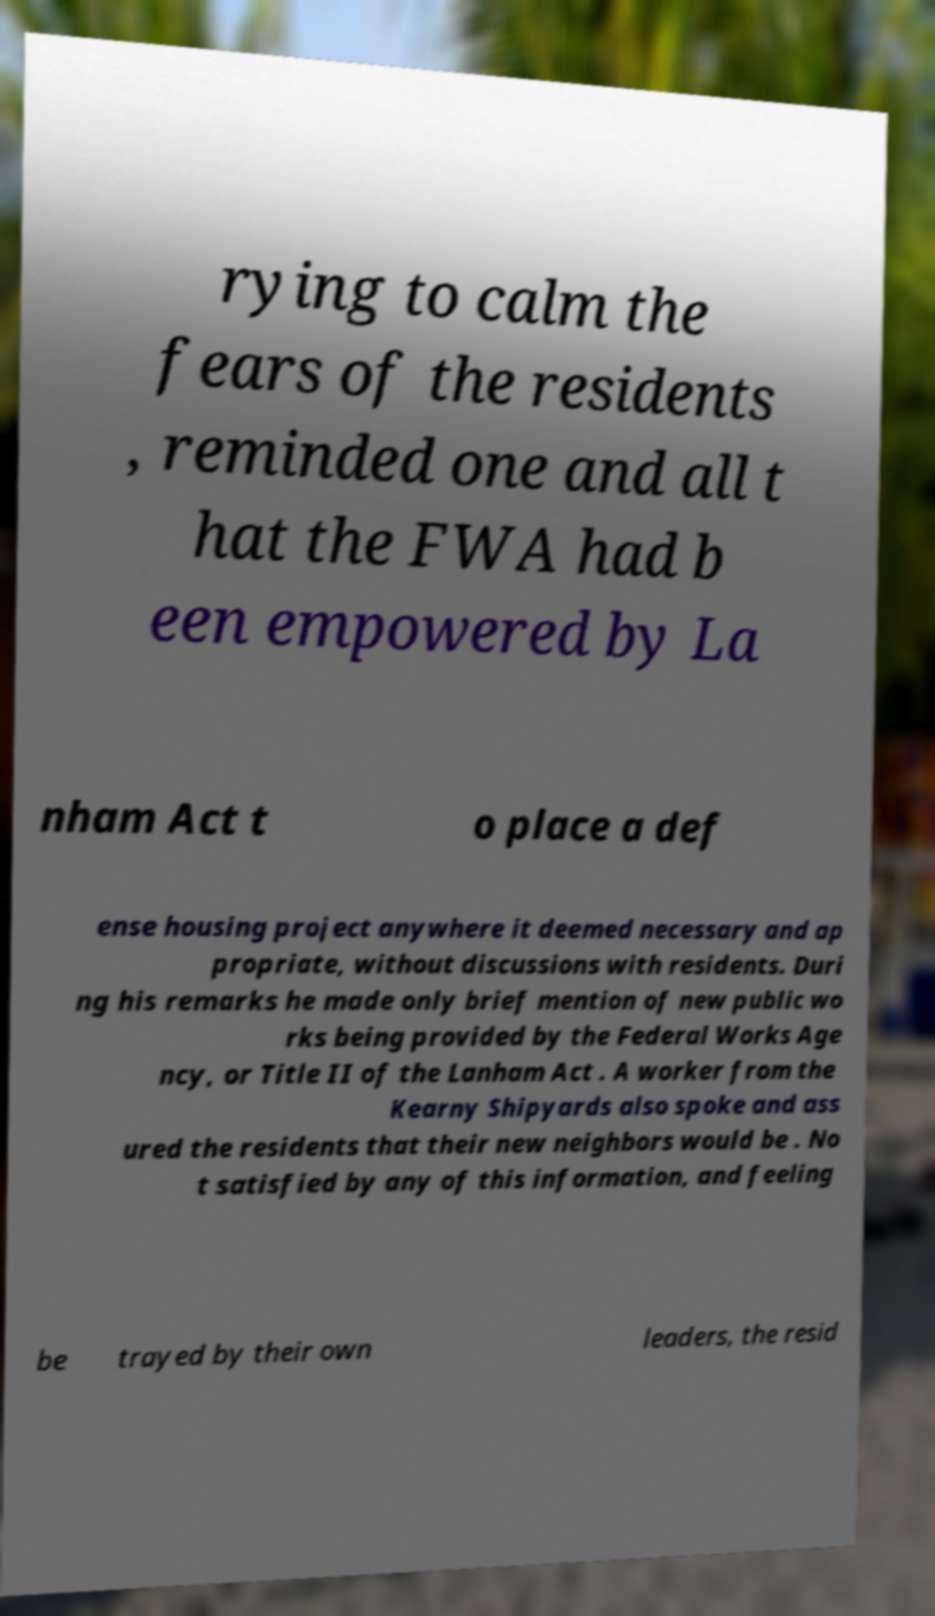Please read and relay the text visible in this image. What does it say? rying to calm the fears of the residents , reminded one and all t hat the FWA had b een empowered by La nham Act t o place a def ense housing project anywhere it deemed necessary and ap propriate, without discussions with residents. Duri ng his remarks he made only brief mention of new public wo rks being provided by the Federal Works Age ncy, or Title II of the Lanham Act . A worker from the Kearny Shipyards also spoke and ass ured the residents that their new neighbors would be . No t satisfied by any of this information, and feeling be trayed by their own leaders, the resid 